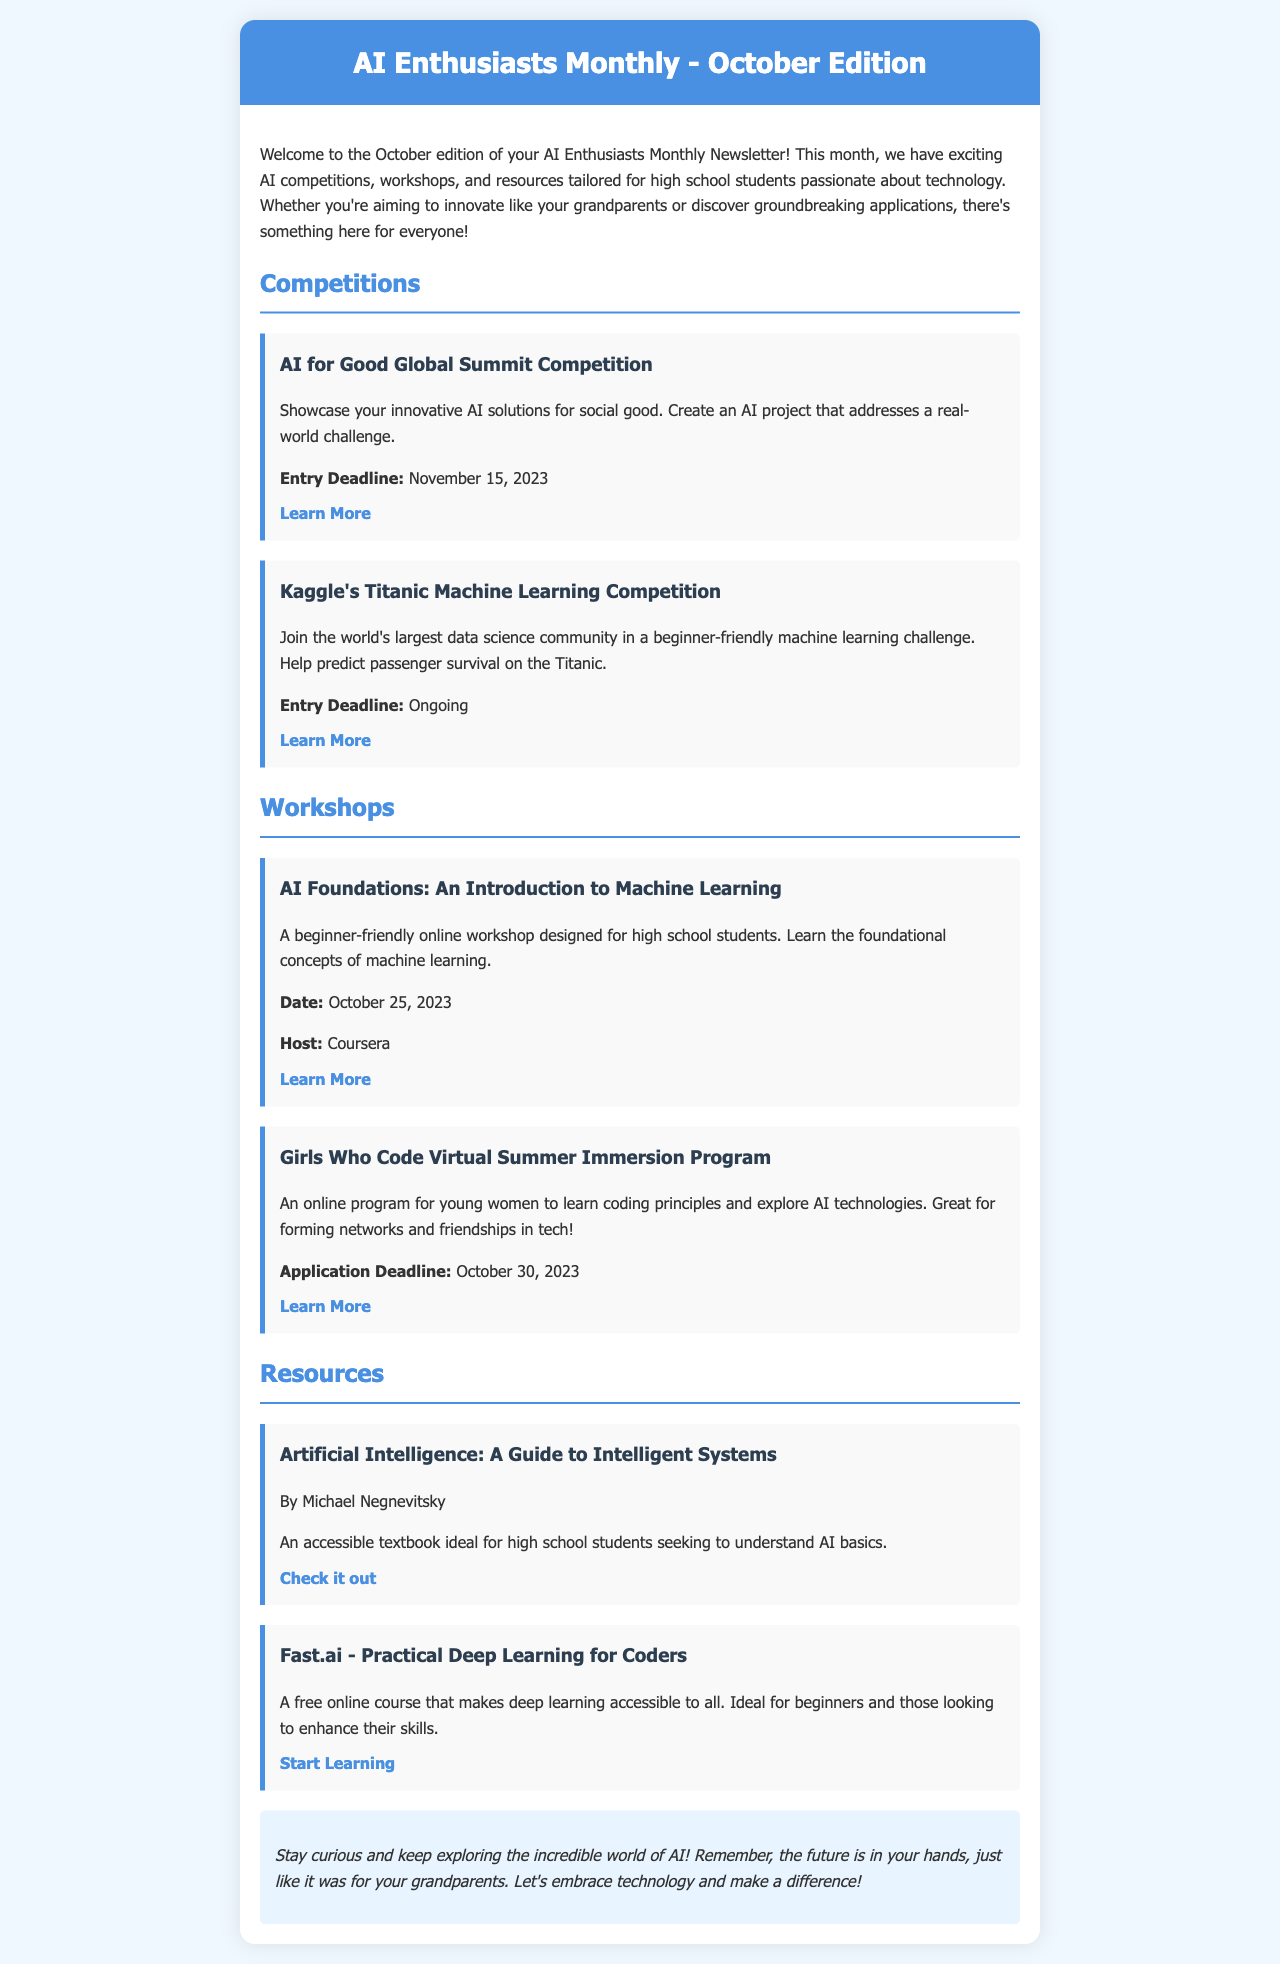What is the title of the newsletter? The title of the newsletter is found in the header section of the document.
Answer: AI Enthusiasts Monthly - October Edition What is the entry deadline for the AI for Good Global Summit Competition? The entry deadline is mentioned under the competition details for this specific event.
Answer: November 15, 2023 Who is hosting the workshop "AI Foundations: An Introduction to Machine Learning"? The host is specified in the workshop details, indicating who is leading the event.
Answer: Coursera What is the application deadline for the Girls Who Code Virtual Summer Immersion Program? The application deadline is provided in the details for this workshop.
Answer: October 30, 2023 Which book is described as ideal for high school students seeking to understand AI basics? The book is listed under the resources section, indicating its purpose and target audience.
Answer: Artificial Intelligence: A Guide to Intelligent Systems How many competitions are listed in the newsletter? The number of competitions can be counted from the competitions section of the document.
Answer: 2 What is the date of the workshop "AI Foundations: An Introduction to Machine Learning"? The date is provided in the workshop's details.
Answer: October 25, 2023 What type of program is the "Girls Who Code Virtual Summer Immersion Program"? The program type is described in the content section outlining its focus and target audience.
Answer: Online program What is the overall theme of the newsletter? The theme is summarized in the introductory paragraph, reflecting the main focus throughout the document.
Answer: AI competitions, workshops, and resources for high school students 